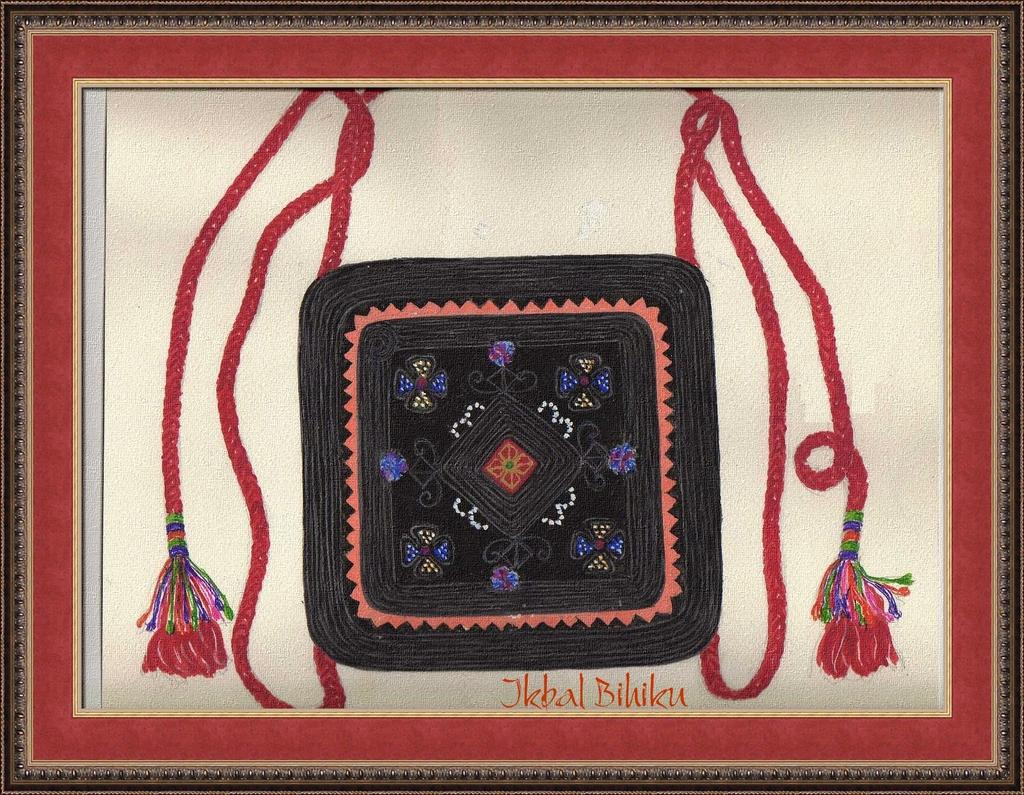Provide a one-sentence caption for the provided image. A piece of artwork created by Jkbal Bihiku is in a frame. 